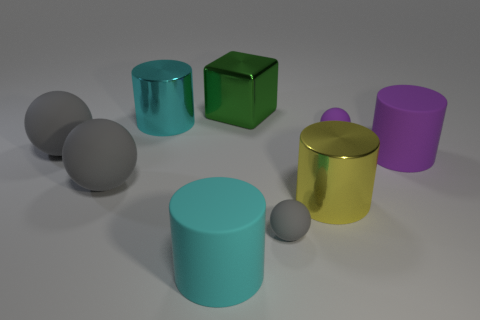There is a large matte object right of the purple rubber ball that is behind the yellow metal object that is in front of the small purple matte thing; what color is it?
Provide a short and direct response. Purple. How many rubber things are either large things or small gray cylinders?
Provide a short and direct response. 4. Is the size of the yellow object the same as the green object?
Offer a terse response. Yes. Is the number of rubber things that are on the right side of the yellow metallic object less than the number of big yellow things that are in front of the big green block?
Offer a terse response. No. Is there anything else that is the same size as the purple matte cylinder?
Offer a very short reply. Yes. What size is the green metallic object?
Your answer should be very brief. Large. How many large objects are green metallic cubes or cyan shiny cylinders?
Your response must be concise. 2. There is a green metallic object; does it have the same size as the metal cylinder left of the tiny gray rubber object?
Keep it short and to the point. Yes. Is there anything else that has the same shape as the large yellow thing?
Provide a short and direct response. Yes. How many cubes are there?
Ensure brevity in your answer.  1. 